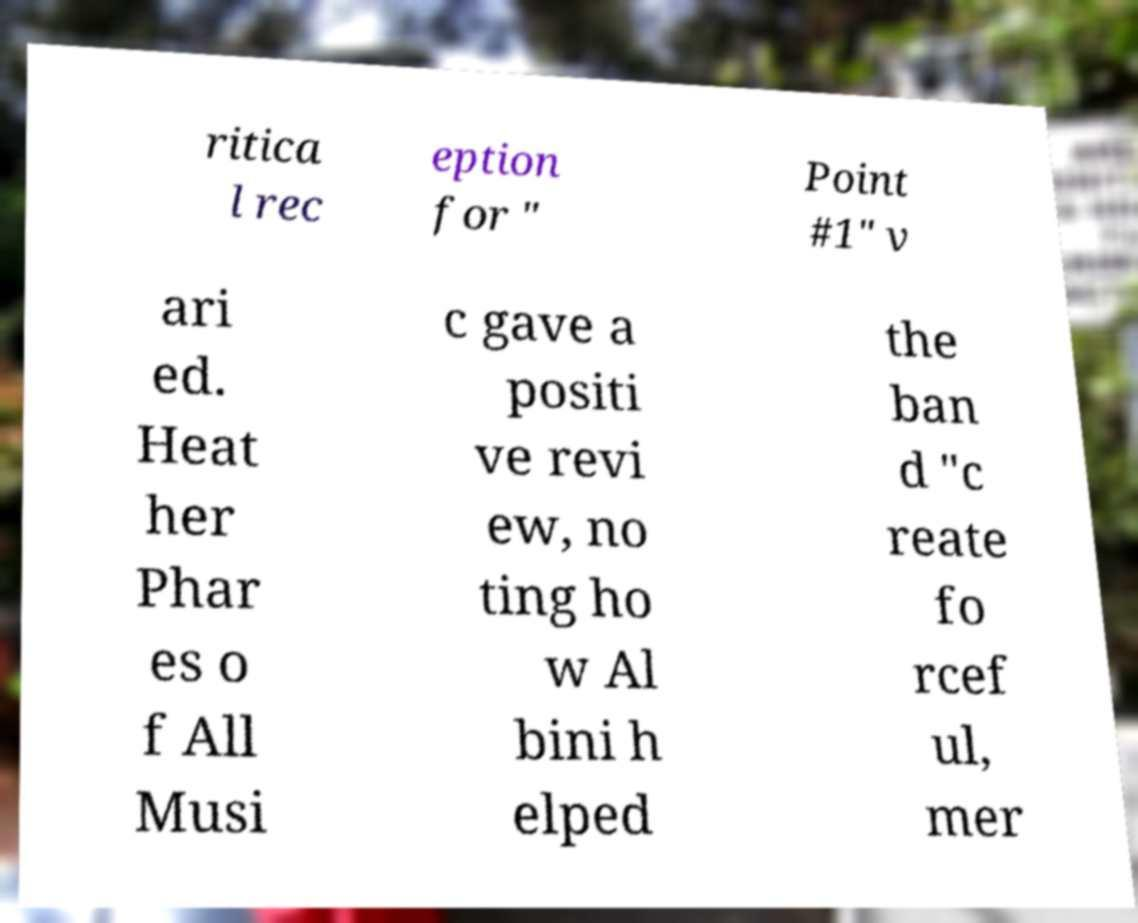For documentation purposes, I need the text within this image transcribed. Could you provide that? ritica l rec eption for " Point #1" v ari ed. Heat her Phar es o f All Musi c gave a positi ve revi ew, no ting ho w Al bini h elped the ban d "c reate fo rcef ul, mer 